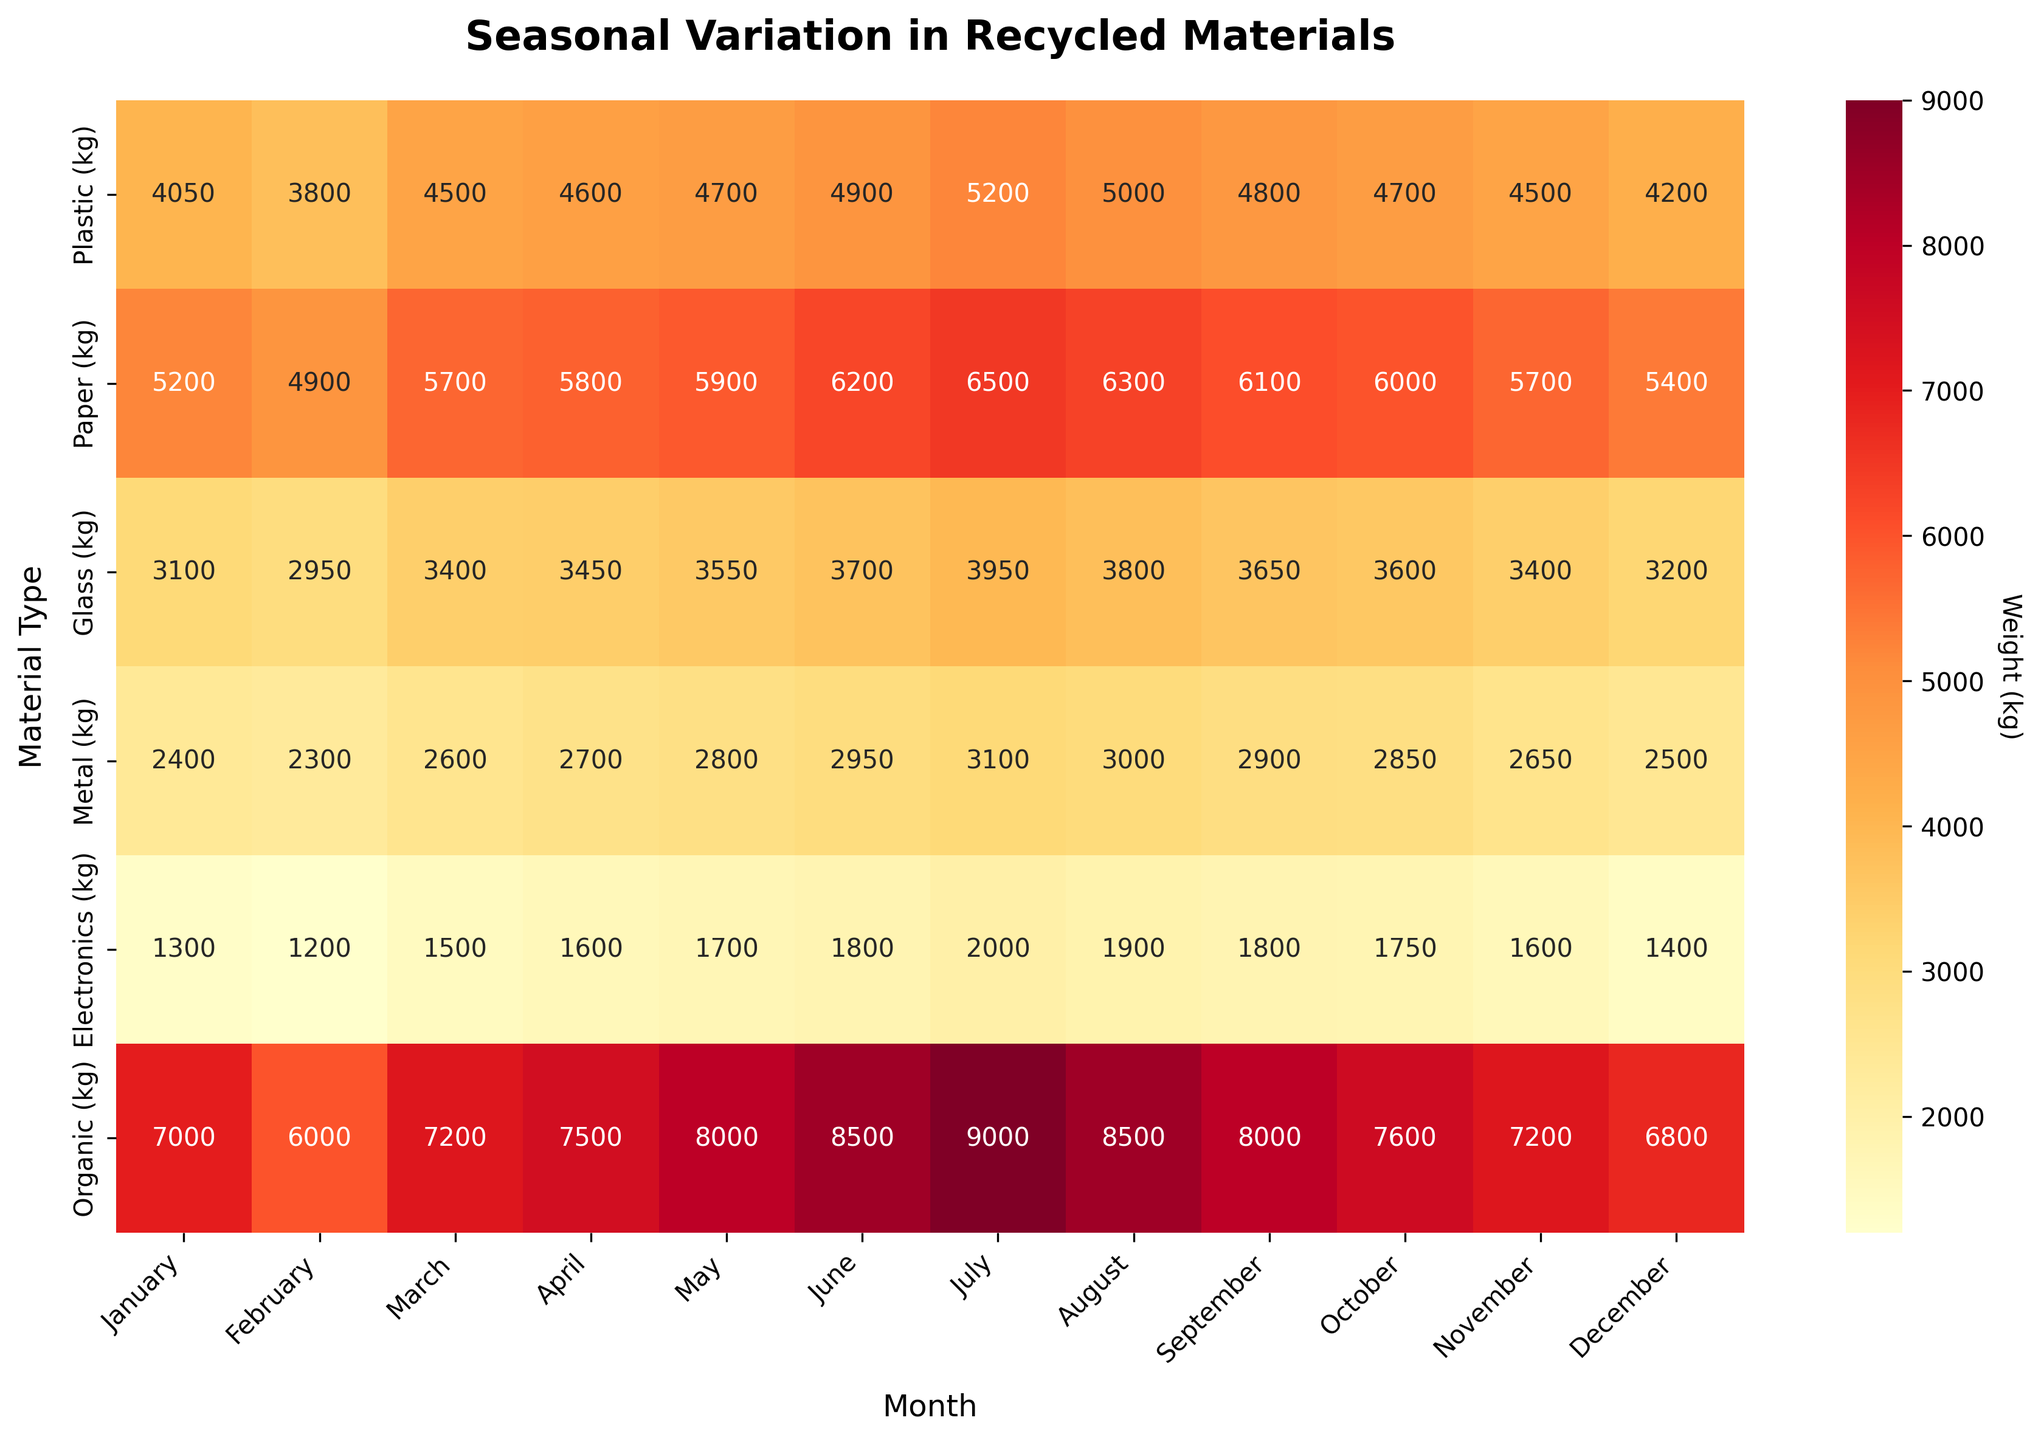What is the title of the heatmap? Look at the top of the heatmap to find the title. It should be clearly written in bold letters.
Answer: Seasonal Variation in Recycled Materials What is the peak month for recycling organic materials? Locate the "Organic" row on the y-axis and identify the month with the highest value in that row.
Answer: July Which material has the highest recycling volume in December? Look at the December column and compare the values for each material to find the highest one.
Answer: Organic (6800 kg) In which month was the least amount of metal recycled? Find the "Metal" row and identify the month with the lowest value.
Answer: February Which two materials saw their highest recycling volumes in June? Check each row for the highest value and then identify the month. Find the materials with peaks in June.
Answer: Plastic and Paper What is the total weight of recycled paper for the entire year? Sum the values in the "Paper" row to get the total weight. Explanation: 5200 + 4900 + 5700 + 5800 + 5900 + 6200 + 6500 + 6300 + 6100 + 6000 + 5700 + 5400 = 70500 kg
Answer: 70500 kg How does the volume of recycled glass in April compare to that in October? Compare the values for "Glass" in April and October to see which is higher.
Answer: April (3450 kg) is higher than October (3600 kg) What is the average amount of plastic recycled per month? Sum the values for the "Plastic" row and divide by 12 (the number of months). Explanation: (4050 + 3800 + 4500 + 4600 + 4700 + 4900 + 5200 + 5000 + 4800 + 4700 + 4500 + 4200) / 12 = 4642 kg
Answer: 4642 kg What months show the lowest activity for recycling electronics? Identify the month(s) with the lowest value in the "Electronics" row.
Answer: February (1200 kg) and March (1500 kg) 